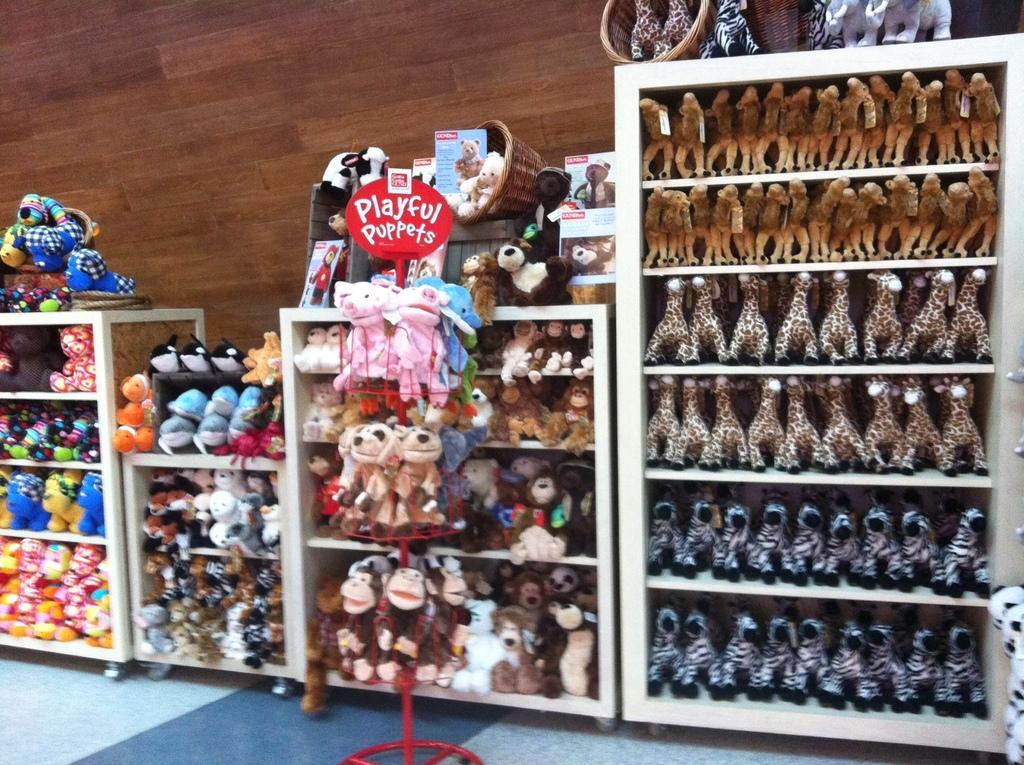What objects are present in the image? There are toys in the image. Where are the toys located? The toys are in racks. Can you describe the position of the racks in the image? The racks are in the center of the image. What type of cloth is draped over the toys in the image? There is no cloth draped over the toys in the image. How many pencils can be seen on the tray in the image? There is no tray or pencils present in the image. 